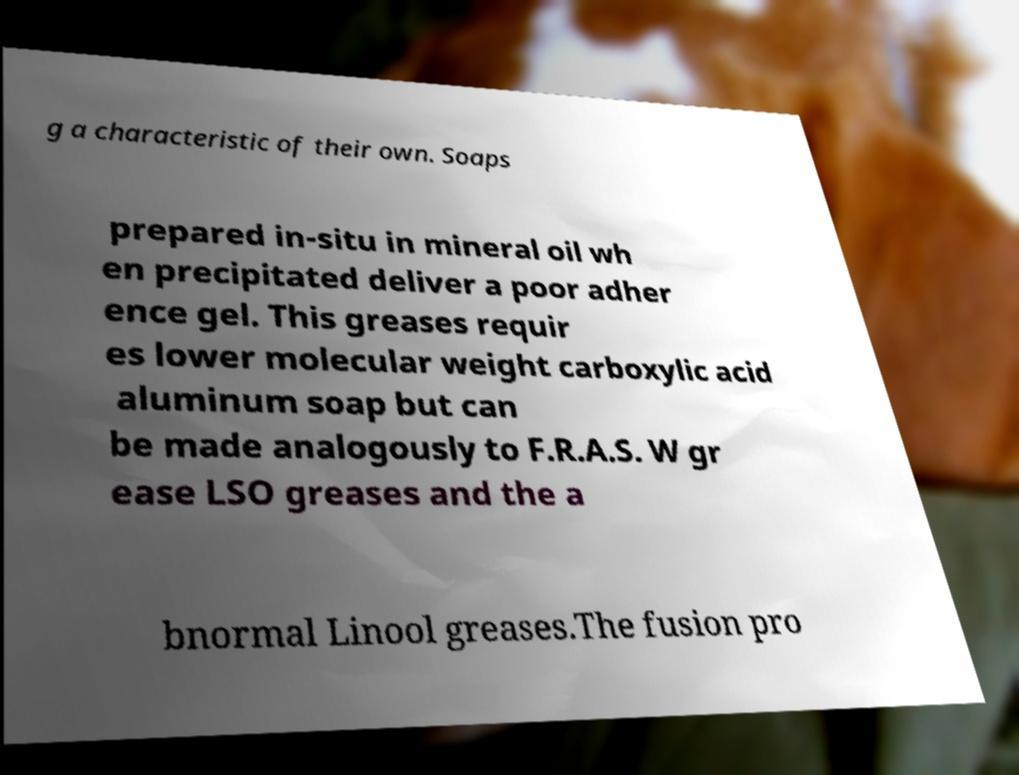Please identify and transcribe the text found in this image. g a characteristic of their own. Soaps prepared in-situ in mineral oil wh en precipitated deliver a poor adher ence gel. This greases requir es lower molecular weight carboxylic acid aluminum soap but can be made analogously to F.R.A.S. W gr ease LSO greases and the a bnormal Linool greases.The fusion pro 